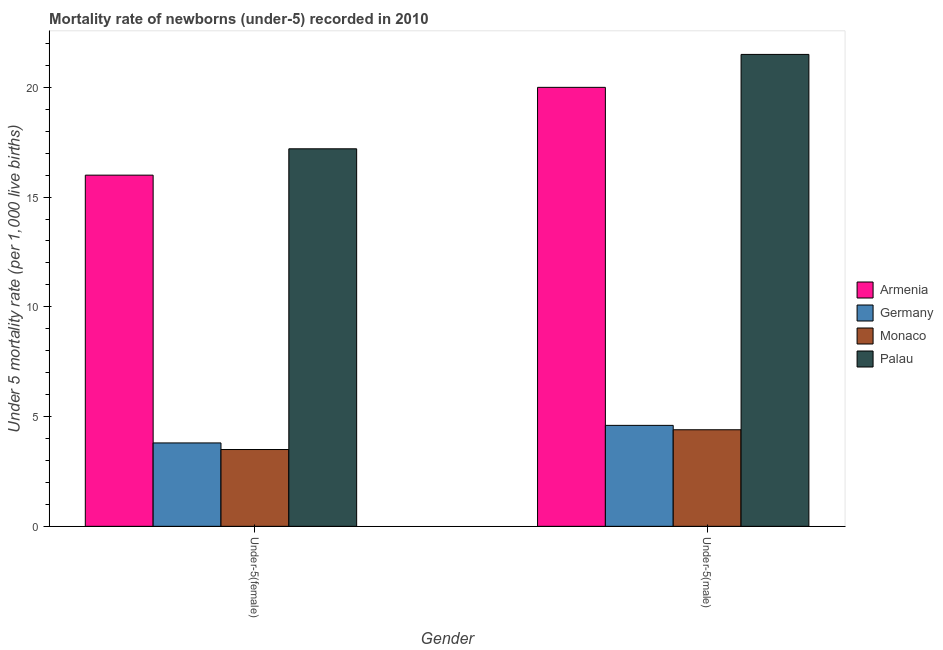Are the number of bars on each tick of the X-axis equal?
Provide a succinct answer. Yes. What is the label of the 2nd group of bars from the left?
Offer a very short reply. Under-5(male). Across all countries, what is the minimum under-5 male mortality rate?
Your answer should be compact. 4.4. In which country was the under-5 female mortality rate maximum?
Your response must be concise. Palau. In which country was the under-5 male mortality rate minimum?
Make the answer very short. Monaco. What is the total under-5 female mortality rate in the graph?
Keep it short and to the point. 40.5. What is the difference between the under-5 male mortality rate in Germany and that in Monaco?
Provide a short and direct response. 0.2. What is the average under-5 female mortality rate per country?
Your answer should be compact. 10.12. What is the difference between the under-5 male mortality rate and under-5 female mortality rate in Germany?
Offer a terse response. 0.8. What is the ratio of the under-5 male mortality rate in Monaco to that in Palau?
Offer a very short reply. 0.2. Is the under-5 female mortality rate in Germany less than that in Armenia?
Your response must be concise. Yes. In how many countries, is the under-5 male mortality rate greater than the average under-5 male mortality rate taken over all countries?
Offer a terse response. 2. What does the 3rd bar from the left in Under-5(female) represents?
Your answer should be very brief. Monaco. What does the 1st bar from the right in Under-5(male) represents?
Give a very brief answer. Palau. How many bars are there?
Your answer should be compact. 8. Are all the bars in the graph horizontal?
Offer a very short reply. No. What is the difference between two consecutive major ticks on the Y-axis?
Your answer should be very brief. 5. Where does the legend appear in the graph?
Offer a terse response. Center right. How many legend labels are there?
Your answer should be compact. 4. How are the legend labels stacked?
Ensure brevity in your answer.  Vertical. What is the title of the graph?
Provide a short and direct response. Mortality rate of newborns (under-5) recorded in 2010. What is the label or title of the Y-axis?
Offer a terse response. Under 5 mortality rate (per 1,0 live births). What is the Under 5 mortality rate (per 1,000 live births) of Armenia in Under-5(female)?
Offer a terse response. 16. What is the Under 5 mortality rate (per 1,000 live births) in Germany in Under-5(female)?
Ensure brevity in your answer.  3.8. What is the Under 5 mortality rate (per 1,000 live births) of Palau in Under-5(female)?
Offer a terse response. 17.2. What is the Under 5 mortality rate (per 1,000 live births) in Palau in Under-5(male)?
Offer a very short reply. 21.5. Across all Gender, what is the maximum Under 5 mortality rate (per 1,000 live births) in Armenia?
Provide a succinct answer. 20. Across all Gender, what is the maximum Under 5 mortality rate (per 1,000 live births) in Monaco?
Your response must be concise. 4.4. Across all Gender, what is the maximum Under 5 mortality rate (per 1,000 live births) of Palau?
Ensure brevity in your answer.  21.5. Across all Gender, what is the minimum Under 5 mortality rate (per 1,000 live births) in Armenia?
Offer a very short reply. 16. Across all Gender, what is the minimum Under 5 mortality rate (per 1,000 live births) of Germany?
Your response must be concise. 3.8. Across all Gender, what is the minimum Under 5 mortality rate (per 1,000 live births) in Monaco?
Offer a very short reply. 3.5. What is the total Under 5 mortality rate (per 1,000 live births) of Armenia in the graph?
Give a very brief answer. 36. What is the total Under 5 mortality rate (per 1,000 live births) in Palau in the graph?
Ensure brevity in your answer.  38.7. What is the difference between the Under 5 mortality rate (per 1,000 live births) in Monaco in Under-5(female) and that in Under-5(male)?
Make the answer very short. -0.9. What is the difference between the Under 5 mortality rate (per 1,000 live births) in Palau in Under-5(female) and that in Under-5(male)?
Ensure brevity in your answer.  -4.3. What is the difference between the Under 5 mortality rate (per 1,000 live births) of Armenia in Under-5(female) and the Under 5 mortality rate (per 1,000 live births) of Germany in Under-5(male)?
Make the answer very short. 11.4. What is the difference between the Under 5 mortality rate (per 1,000 live births) of Germany in Under-5(female) and the Under 5 mortality rate (per 1,000 live births) of Monaco in Under-5(male)?
Keep it short and to the point. -0.6. What is the difference between the Under 5 mortality rate (per 1,000 live births) of Germany in Under-5(female) and the Under 5 mortality rate (per 1,000 live births) of Palau in Under-5(male)?
Provide a short and direct response. -17.7. What is the average Under 5 mortality rate (per 1,000 live births) of Germany per Gender?
Offer a terse response. 4.2. What is the average Under 5 mortality rate (per 1,000 live births) in Monaco per Gender?
Offer a very short reply. 3.95. What is the average Under 5 mortality rate (per 1,000 live births) in Palau per Gender?
Make the answer very short. 19.35. What is the difference between the Under 5 mortality rate (per 1,000 live births) in Armenia and Under 5 mortality rate (per 1,000 live births) in Germany in Under-5(female)?
Keep it short and to the point. 12.2. What is the difference between the Under 5 mortality rate (per 1,000 live births) of Armenia and Under 5 mortality rate (per 1,000 live births) of Monaco in Under-5(female)?
Ensure brevity in your answer.  12.5. What is the difference between the Under 5 mortality rate (per 1,000 live births) of Germany and Under 5 mortality rate (per 1,000 live births) of Monaco in Under-5(female)?
Your answer should be compact. 0.3. What is the difference between the Under 5 mortality rate (per 1,000 live births) in Germany and Under 5 mortality rate (per 1,000 live births) in Palau in Under-5(female)?
Provide a short and direct response. -13.4. What is the difference between the Under 5 mortality rate (per 1,000 live births) in Monaco and Under 5 mortality rate (per 1,000 live births) in Palau in Under-5(female)?
Offer a very short reply. -13.7. What is the difference between the Under 5 mortality rate (per 1,000 live births) in Armenia and Under 5 mortality rate (per 1,000 live births) in Monaco in Under-5(male)?
Give a very brief answer. 15.6. What is the difference between the Under 5 mortality rate (per 1,000 live births) of Armenia and Under 5 mortality rate (per 1,000 live births) of Palau in Under-5(male)?
Ensure brevity in your answer.  -1.5. What is the difference between the Under 5 mortality rate (per 1,000 live births) of Germany and Under 5 mortality rate (per 1,000 live births) of Palau in Under-5(male)?
Offer a terse response. -16.9. What is the difference between the Under 5 mortality rate (per 1,000 live births) in Monaco and Under 5 mortality rate (per 1,000 live births) in Palau in Under-5(male)?
Provide a succinct answer. -17.1. What is the ratio of the Under 5 mortality rate (per 1,000 live births) of Armenia in Under-5(female) to that in Under-5(male)?
Make the answer very short. 0.8. What is the ratio of the Under 5 mortality rate (per 1,000 live births) in Germany in Under-5(female) to that in Under-5(male)?
Provide a succinct answer. 0.83. What is the ratio of the Under 5 mortality rate (per 1,000 live births) in Monaco in Under-5(female) to that in Under-5(male)?
Your answer should be very brief. 0.8. What is the difference between the highest and the second highest Under 5 mortality rate (per 1,000 live births) in Germany?
Offer a very short reply. 0.8. What is the difference between the highest and the second highest Under 5 mortality rate (per 1,000 live births) in Palau?
Give a very brief answer. 4.3. What is the difference between the highest and the lowest Under 5 mortality rate (per 1,000 live births) of Germany?
Your answer should be very brief. 0.8. What is the difference between the highest and the lowest Under 5 mortality rate (per 1,000 live births) of Monaco?
Keep it short and to the point. 0.9. 